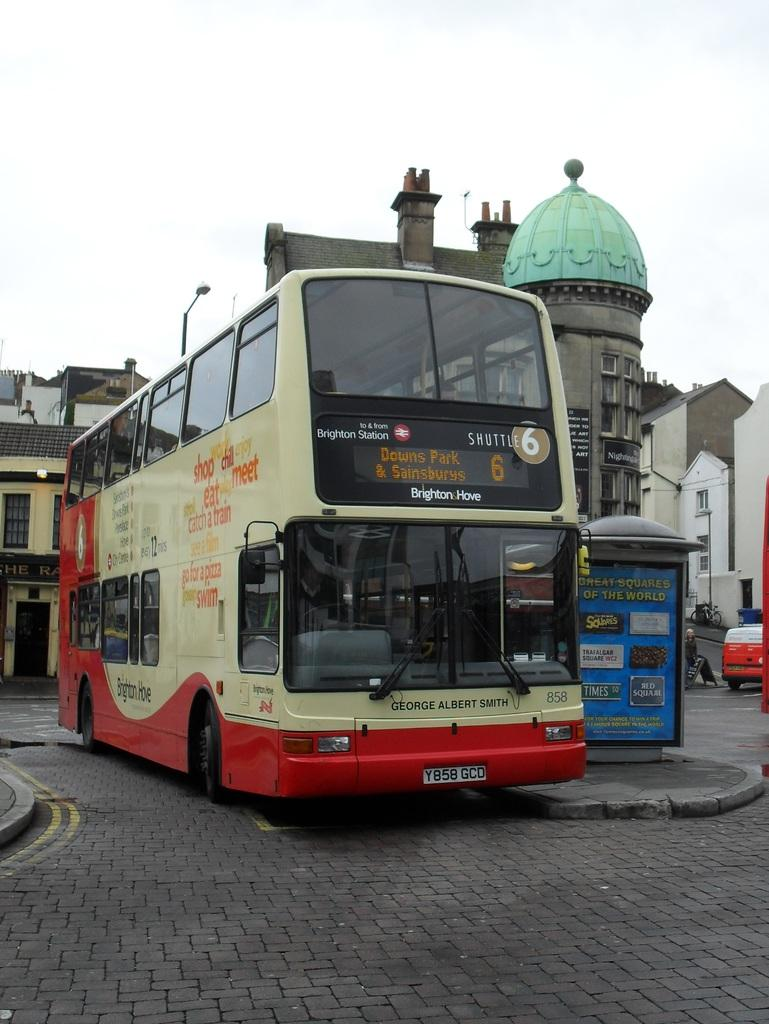What is happening on the road in the image? There are vehicles on the road in the image. What can be seen in the distance behind the vehicles? There are buildings, poles, and boards in the background of the image. What is visible at the top of the image? The sky is visible at the top of the image. Where is the camera located in the image? There is no camera visible in the image. Is there a beggar asking for money in the image? There is no beggar present in the image. 